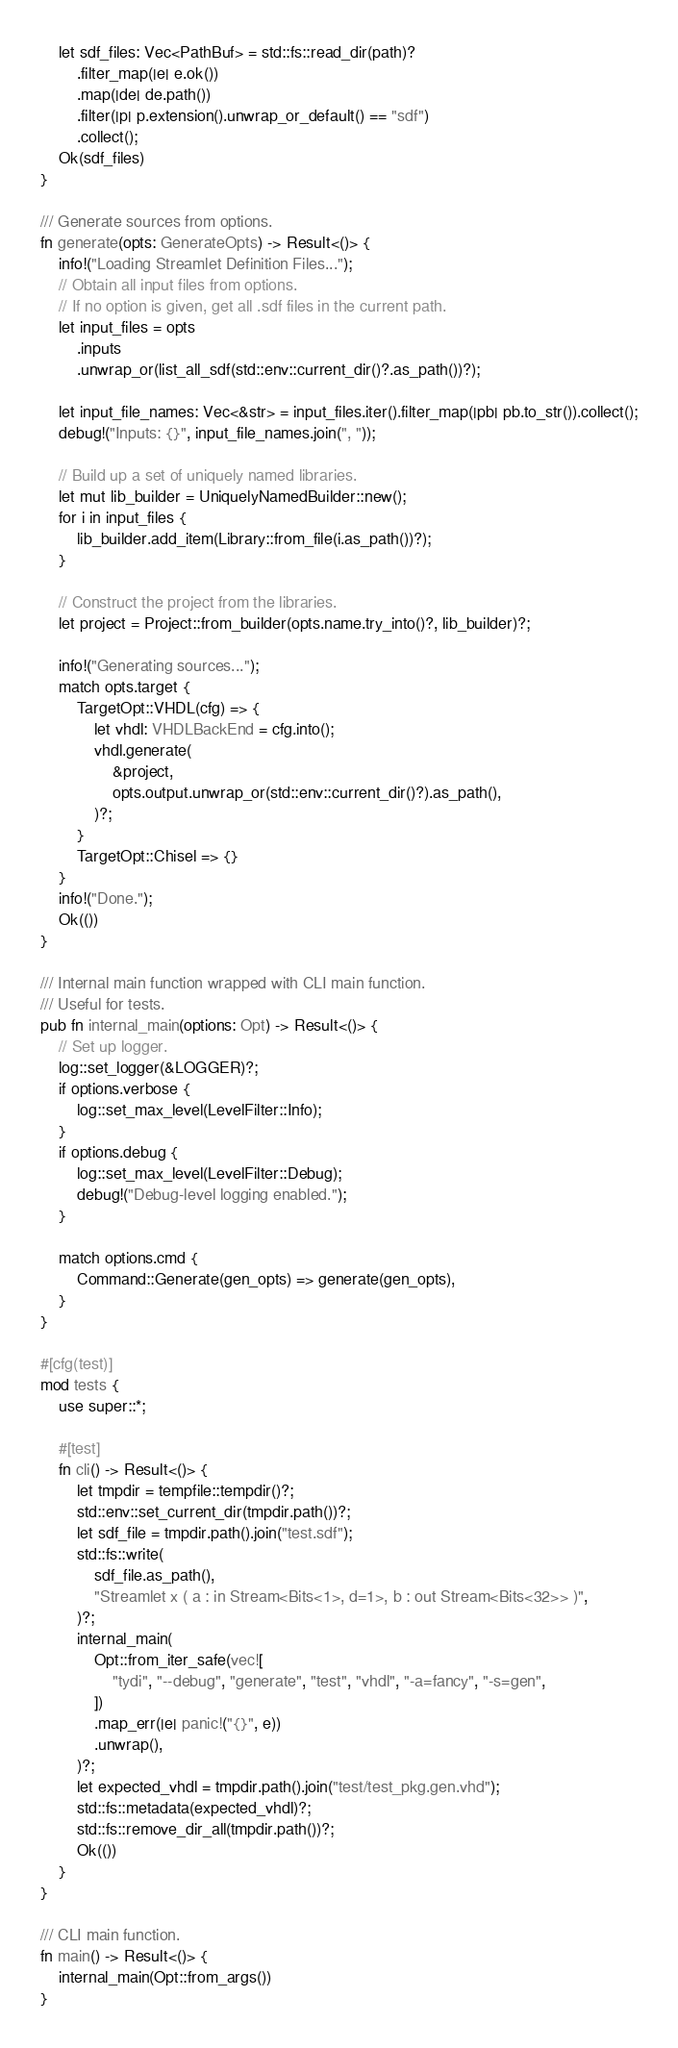<code> <loc_0><loc_0><loc_500><loc_500><_Rust_>    let sdf_files: Vec<PathBuf> = std::fs::read_dir(path)?
        .filter_map(|e| e.ok())
        .map(|de| de.path())
        .filter(|p| p.extension().unwrap_or_default() == "sdf")
        .collect();
    Ok(sdf_files)
}

/// Generate sources from options.
fn generate(opts: GenerateOpts) -> Result<()> {
    info!("Loading Streamlet Definition Files...");
    // Obtain all input files from options.
    // If no option is given, get all .sdf files in the current path.
    let input_files = opts
        .inputs
        .unwrap_or(list_all_sdf(std::env::current_dir()?.as_path())?);

    let input_file_names: Vec<&str> = input_files.iter().filter_map(|pb| pb.to_str()).collect();
    debug!("Inputs: {}", input_file_names.join(", "));

    // Build up a set of uniquely named libraries.
    let mut lib_builder = UniquelyNamedBuilder::new();
    for i in input_files {
        lib_builder.add_item(Library::from_file(i.as_path())?);
    }

    // Construct the project from the libraries.
    let project = Project::from_builder(opts.name.try_into()?, lib_builder)?;

    info!("Generating sources...");
    match opts.target {
        TargetOpt::VHDL(cfg) => {
            let vhdl: VHDLBackEnd = cfg.into();
            vhdl.generate(
                &project,
                opts.output.unwrap_or(std::env::current_dir()?).as_path(),
            )?;
        }
        TargetOpt::Chisel => {}
    }
    info!("Done.");
    Ok(())
}

/// Internal main function wrapped with CLI main function.
/// Useful for tests.
pub fn internal_main(options: Opt) -> Result<()> {
    // Set up logger.
    log::set_logger(&LOGGER)?;
    if options.verbose {
        log::set_max_level(LevelFilter::Info);
    }
    if options.debug {
        log::set_max_level(LevelFilter::Debug);
        debug!("Debug-level logging enabled.");
    }

    match options.cmd {
        Command::Generate(gen_opts) => generate(gen_opts),
    }
}

#[cfg(test)]
mod tests {
    use super::*;

    #[test]
    fn cli() -> Result<()> {
        let tmpdir = tempfile::tempdir()?;
        std::env::set_current_dir(tmpdir.path())?;
        let sdf_file = tmpdir.path().join("test.sdf");
        std::fs::write(
            sdf_file.as_path(),
            "Streamlet x ( a : in Stream<Bits<1>, d=1>, b : out Stream<Bits<32>> )",
        )?;
        internal_main(
            Opt::from_iter_safe(vec![
                "tydi", "--debug", "generate", "test", "vhdl", "-a=fancy", "-s=gen",
            ])
            .map_err(|e| panic!("{}", e))
            .unwrap(),
        )?;
        let expected_vhdl = tmpdir.path().join("test/test_pkg.gen.vhd");
        std::fs::metadata(expected_vhdl)?;
        std::fs::remove_dir_all(tmpdir.path())?;
        Ok(())
    }
}

/// CLI main function.
fn main() -> Result<()> {
    internal_main(Opt::from_args())
}
</code> 